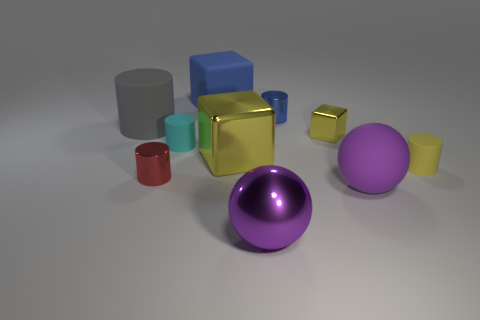Subtract 1 cylinders. How many cylinders are left? 4 Subtract all yellow matte cylinders. How many cylinders are left? 4 Subtract all gray cylinders. How many cylinders are left? 4 Subtract all purple cylinders. Subtract all blue blocks. How many cylinders are left? 5 Subtract all balls. How many objects are left? 8 Add 1 big purple metal spheres. How many big purple metal spheres are left? 2 Add 6 big blue cylinders. How many big blue cylinders exist? 6 Subtract 1 red cylinders. How many objects are left? 9 Subtract all large red cubes. Subtract all big gray objects. How many objects are left? 9 